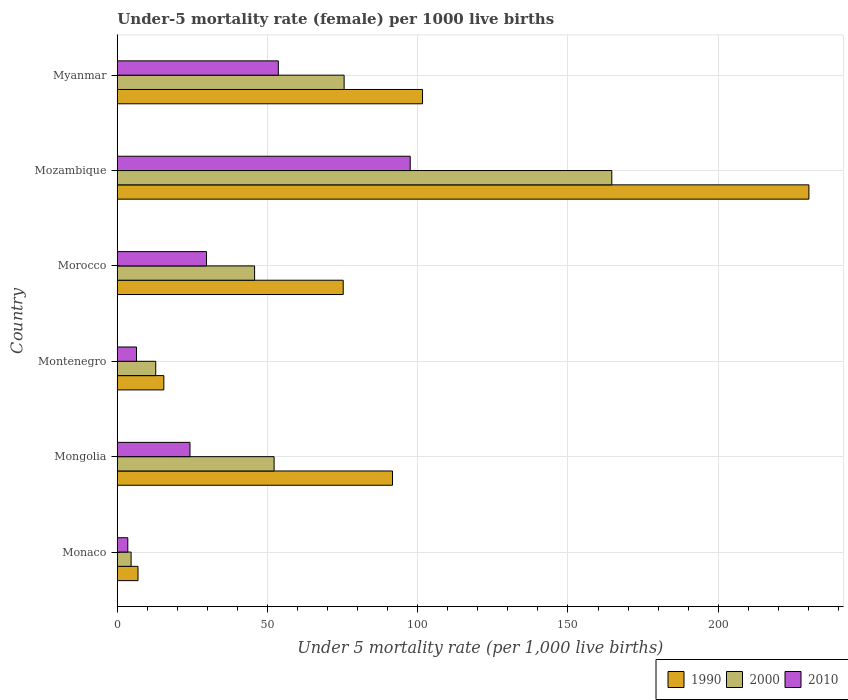How many different coloured bars are there?
Ensure brevity in your answer.  3. Are the number of bars per tick equal to the number of legend labels?
Your answer should be very brief. Yes. Are the number of bars on each tick of the Y-axis equal?
Provide a succinct answer. Yes. How many bars are there on the 4th tick from the top?
Provide a succinct answer. 3. What is the label of the 4th group of bars from the top?
Your answer should be compact. Montenegro. In how many cases, is the number of bars for a given country not equal to the number of legend labels?
Ensure brevity in your answer.  0. What is the under-five mortality rate in 2000 in Myanmar?
Offer a terse response. 75.5. Across all countries, what is the maximum under-five mortality rate in 1990?
Your response must be concise. 230.2. Across all countries, what is the minimum under-five mortality rate in 2000?
Provide a short and direct response. 4.6. In which country was the under-five mortality rate in 1990 maximum?
Your answer should be compact. Mozambique. In which country was the under-five mortality rate in 1990 minimum?
Keep it short and to the point. Monaco. What is the total under-five mortality rate in 2010 in the graph?
Your answer should be very brief. 214.9. What is the difference between the under-five mortality rate in 2000 in Mongolia and that in Mozambique?
Give a very brief answer. -112.4. What is the difference between the under-five mortality rate in 1990 in Myanmar and the under-five mortality rate in 2010 in Montenegro?
Make the answer very short. 95.2. What is the average under-five mortality rate in 2010 per country?
Offer a very short reply. 35.82. What is the difference between the under-five mortality rate in 2010 and under-five mortality rate in 1990 in Morocco?
Provide a succinct answer. -45.5. In how many countries, is the under-five mortality rate in 1990 greater than 220 ?
Give a very brief answer. 1. What is the ratio of the under-five mortality rate in 2000 in Morocco to that in Mozambique?
Keep it short and to the point. 0.28. What is the difference between the highest and the second highest under-five mortality rate in 2010?
Give a very brief answer. 43.9. What is the difference between the highest and the lowest under-five mortality rate in 2000?
Your answer should be very brief. 160. Is the sum of the under-five mortality rate in 2000 in Monaco and Morocco greater than the maximum under-five mortality rate in 1990 across all countries?
Your response must be concise. No. What does the 1st bar from the bottom in Montenegro represents?
Provide a short and direct response. 1990. Is it the case that in every country, the sum of the under-five mortality rate in 2010 and under-five mortality rate in 1990 is greater than the under-five mortality rate in 2000?
Offer a terse response. Yes. How many countries are there in the graph?
Your answer should be compact. 6. Where does the legend appear in the graph?
Keep it short and to the point. Bottom right. How are the legend labels stacked?
Offer a very short reply. Horizontal. What is the title of the graph?
Ensure brevity in your answer.  Under-5 mortality rate (female) per 1000 live births. What is the label or title of the X-axis?
Provide a short and direct response. Under 5 mortality rate (per 1,0 live births). What is the label or title of the Y-axis?
Ensure brevity in your answer.  Country. What is the Under 5 mortality rate (per 1,000 live births) in 1990 in Monaco?
Ensure brevity in your answer.  6.9. What is the Under 5 mortality rate (per 1,000 live births) in 2000 in Monaco?
Your answer should be compact. 4.6. What is the Under 5 mortality rate (per 1,000 live births) in 2010 in Monaco?
Offer a terse response. 3.5. What is the Under 5 mortality rate (per 1,000 live births) of 1990 in Mongolia?
Provide a succinct answer. 91.6. What is the Under 5 mortality rate (per 1,000 live births) in 2000 in Mongolia?
Provide a succinct answer. 52.2. What is the Under 5 mortality rate (per 1,000 live births) of 2010 in Mongolia?
Make the answer very short. 24.2. What is the Under 5 mortality rate (per 1,000 live births) of 1990 in Montenegro?
Provide a succinct answer. 15.5. What is the Under 5 mortality rate (per 1,000 live births) of 2010 in Montenegro?
Ensure brevity in your answer.  6.4. What is the Under 5 mortality rate (per 1,000 live births) of 1990 in Morocco?
Make the answer very short. 75.2. What is the Under 5 mortality rate (per 1,000 live births) of 2000 in Morocco?
Provide a short and direct response. 45.7. What is the Under 5 mortality rate (per 1,000 live births) of 2010 in Morocco?
Provide a succinct answer. 29.7. What is the Under 5 mortality rate (per 1,000 live births) in 1990 in Mozambique?
Offer a very short reply. 230.2. What is the Under 5 mortality rate (per 1,000 live births) in 2000 in Mozambique?
Keep it short and to the point. 164.6. What is the Under 5 mortality rate (per 1,000 live births) in 2010 in Mozambique?
Keep it short and to the point. 97.5. What is the Under 5 mortality rate (per 1,000 live births) in 1990 in Myanmar?
Your answer should be compact. 101.6. What is the Under 5 mortality rate (per 1,000 live births) in 2000 in Myanmar?
Keep it short and to the point. 75.5. What is the Under 5 mortality rate (per 1,000 live births) in 2010 in Myanmar?
Provide a succinct answer. 53.6. Across all countries, what is the maximum Under 5 mortality rate (per 1,000 live births) in 1990?
Keep it short and to the point. 230.2. Across all countries, what is the maximum Under 5 mortality rate (per 1,000 live births) of 2000?
Ensure brevity in your answer.  164.6. Across all countries, what is the maximum Under 5 mortality rate (per 1,000 live births) of 2010?
Ensure brevity in your answer.  97.5. Across all countries, what is the minimum Under 5 mortality rate (per 1,000 live births) in 2010?
Your response must be concise. 3.5. What is the total Under 5 mortality rate (per 1,000 live births) in 1990 in the graph?
Provide a short and direct response. 521. What is the total Under 5 mortality rate (per 1,000 live births) in 2000 in the graph?
Keep it short and to the point. 355.4. What is the total Under 5 mortality rate (per 1,000 live births) in 2010 in the graph?
Your response must be concise. 214.9. What is the difference between the Under 5 mortality rate (per 1,000 live births) of 1990 in Monaco and that in Mongolia?
Keep it short and to the point. -84.7. What is the difference between the Under 5 mortality rate (per 1,000 live births) in 2000 in Monaco and that in Mongolia?
Provide a succinct answer. -47.6. What is the difference between the Under 5 mortality rate (per 1,000 live births) of 2010 in Monaco and that in Mongolia?
Offer a terse response. -20.7. What is the difference between the Under 5 mortality rate (per 1,000 live births) in 1990 in Monaco and that in Montenegro?
Offer a terse response. -8.6. What is the difference between the Under 5 mortality rate (per 1,000 live births) in 2010 in Monaco and that in Montenegro?
Your answer should be compact. -2.9. What is the difference between the Under 5 mortality rate (per 1,000 live births) of 1990 in Monaco and that in Morocco?
Provide a succinct answer. -68.3. What is the difference between the Under 5 mortality rate (per 1,000 live births) of 2000 in Monaco and that in Morocco?
Provide a short and direct response. -41.1. What is the difference between the Under 5 mortality rate (per 1,000 live births) in 2010 in Monaco and that in Morocco?
Provide a short and direct response. -26.2. What is the difference between the Under 5 mortality rate (per 1,000 live births) in 1990 in Monaco and that in Mozambique?
Ensure brevity in your answer.  -223.3. What is the difference between the Under 5 mortality rate (per 1,000 live births) in 2000 in Monaco and that in Mozambique?
Your answer should be very brief. -160. What is the difference between the Under 5 mortality rate (per 1,000 live births) in 2010 in Monaco and that in Mozambique?
Your answer should be very brief. -94. What is the difference between the Under 5 mortality rate (per 1,000 live births) in 1990 in Monaco and that in Myanmar?
Provide a succinct answer. -94.7. What is the difference between the Under 5 mortality rate (per 1,000 live births) in 2000 in Monaco and that in Myanmar?
Make the answer very short. -70.9. What is the difference between the Under 5 mortality rate (per 1,000 live births) in 2010 in Monaco and that in Myanmar?
Your response must be concise. -50.1. What is the difference between the Under 5 mortality rate (per 1,000 live births) in 1990 in Mongolia and that in Montenegro?
Your answer should be very brief. 76.1. What is the difference between the Under 5 mortality rate (per 1,000 live births) of 2000 in Mongolia and that in Montenegro?
Your answer should be compact. 39.4. What is the difference between the Under 5 mortality rate (per 1,000 live births) of 1990 in Mongolia and that in Morocco?
Your answer should be compact. 16.4. What is the difference between the Under 5 mortality rate (per 1,000 live births) in 1990 in Mongolia and that in Mozambique?
Give a very brief answer. -138.6. What is the difference between the Under 5 mortality rate (per 1,000 live births) of 2000 in Mongolia and that in Mozambique?
Ensure brevity in your answer.  -112.4. What is the difference between the Under 5 mortality rate (per 1,000 live births) in 2010 in Mongolia and that in Mozambique?
Make the answer very short. -73.3. What is the difference between the Under 5 mortality rate (per 1,000 live births) of 1990 in Mongolia and that in Myanmar?
Ensure brevity in your answer.  -10. What is the difference between the Under 5 mortality rate (per 1,000 live births) in 2000 in Mongolia and that in Myanmar?
Give a very brief answer. -23.3. What is the difference between the Under 5 mortality rate (per 1,000 live births) of 2010 in Mongolia and that in Myanmar?
Offer a terse response. -29.4. What is the difference between the Under 5 mortality rate (per 1,000 live births) of 1990 in Montenegro and that in Morocco?
Your response must be concise. -59.7. What is the difference between the Under 5 mortality rate (per 1,000 live births) in 2000 in Montenegro and that in Morocco?
Keep it short and to the point. -32.9. What is the difference between the Under 5 mortality rate (per 1,000 live births) in 2010 in Montenegro and that in Morocco?
Keep it short and to the point. -23.3. What is the difference between the Under 5 mortality rate (per 1,000 live births) of 1990 in Montenegro and that in Mozambique?
Provide a succinct answer. -214.7. What is the difference between the Under 5 mortality rate (per 1,000 live births) in 2000 in Montenegro and that in Mozambique?
Ensure brevity in your answer.  -151.8. What is the difference between the Under 5 mortality rate (per 1,000 live births) of 2010 in Montenegro and that in Mozambique?
Your answer should be compact. -91.1. What is the difference between the Under 5 mortality rate (per 1,000 live births) in 1990 in Montenegro and that in Myanmar?
Give a very brief answer. -86.1. What is the difference between the Under 5 mortality rate (per 1,000 live births) of 2000 in Montenegro and that in Myanmar?
Your response must be concise. -62.7. What is the difference between the Under 5 mortality rate (per 1,000 live births) in 2010 in Montenegro and that in Myanmar?
Provide a succinct answer. -47.2. What is the difference between the Under 5 mortality rate (per 1,000 live births) in 1990 in Morocco and that in Mozambique?
Your answer should be very brief. -155. What is the difference between the Under 5 mortality rate (per 1,000 live births) in 2000 in Morocco and that in Mozambique?
Offer a terse response. -118.9. What is the difference between the Under 5 mortality rate (per 1,000 live births) of 2010 in Morocco and that in Mozambique?
Provide a succinct answer. -67.8. What is the difference between the Under 5 mortality rate (per 1,000 live births) in 1990 in Morocco and that in Myanmar?
Offer a very short reply. -26.4. What is the difference between the Under 5 mortality rate (per 1,000 live births) of 2000 in Morocco and that in Myanmar?
Give a very brief answer. -29.8. What is the difference between the Under 5 mortality rate (per 1,000 live births) of 2010 in Morocco and that in Myanmar?
Your answer should be compact. -23.9. What is the difference between the Under 5 mortality rate (per 1,000 live births) in 1990 in Mozambique and that in Myanmar?
Offer a terse response. 128.6. What is the difference between the Under 5 mortality rate (per 1,000 live births) of 2000 in Mozambique and that in Myanmar?
Provide a succinct answer. 89.1. What is the difference between the Under 5 mortality rate (per 1,000 live births) in 2010 in Mozambique and that in Myanmar?
Your answer should be very brief. 43.9. What is the difference between the Under 5 mortality rate (per 1,000 live births) of 1990 in Monaco and the Under 5 mortality rate (per 1,000 live births) of 2000 in Mongolia?
Your answer should be very brief. -45.3. What is the difference between the Under 5 mortality rate (per 1,000 live births) in 1990 in Monaco and the Under 5 mortality rate (per 1,000 live births) in 2010 in Mongolia?
Your answer should be very brief. -17.3. What is the difference between the Under 5 mortality rate (per 1,000 live births) of 2000 in Monaco and the Under 5 mortality rate (per 1,000 live births) of 2010 in Mongolia?
Your answer should be compact. -19.6. What is the difference between the Under 5 mortality rate (per 1,000 live births) in 1990 in Monaco and the Under 5 mortality rate (per 1,000 live births) in 2000 in Morocco?
Your answer should be very brief. -38.8. What is the difference between the Under 5 mortality rate (per 1,000 live births) of 1990 in Monaco and the Under 5 mortality rate (per 1,000 live births) of 2010 in Morocco?
Offer a very short reply. -22.8. What is the difference between the Under 5 mortality rate (per 1,000 live births) in 2000 in Monaco and the Under 5 mortality rate (per 1,000 live births) in 2010 in Morocco?
Your answer should be compact. -25.1. What is the difference between the Under 5 mortality rate (per 1,000 live births) of 1990 in Monaco and the Under 5 mortality rate (per 1,000 live births) of 2000 in Mozambique?
Provide a short and direct response. -157.7. What is the difference between the Under 5 mortality rate (per 1,000 live births) in 1990 in Monaco and the Under 5 mortality rate (per 1,000 live births) in 2010 in Mozambique?
Your answer should be very brief. -90.6. What is the difference between the Under 5 mortality rate (per 1,000 live births) of 2000 in Monaco and the Under 5 mortality rate (per 1,000 live births) of 2010 in Mozambique?
Your answer should be very brief. -92.9. What is the difference between the Under 5 mortality rate (per 1,000 live births) in 1990 in Monaco and the Under 5 mortality rate (per 1,000 live births) in 2000 in Myanmar?
Your response must be concise. -68.6. What is the difference between the Under 5 mortality rate (per 1,000 live births) in 1990 in Monaco and the Under 5 mortality rate (per 1,000 live births) in 2010 in Myanmar?
Provide a short and direct response. -46.7. What is the difference between the Under 5 mortality rate (per 1,000 live births) of 2000 in Monaco and the Under 5 mortality rate (per 1,000 live births) of 2010 in Myanmar?
Your answer should be very brief. -49. What is the difference between the Under 5 mortality rate (per 1,000 live births) in 1990 in Mongolia and the Under 5 mortality rate (per 1,000 live births) in 2000 in Montenegro?
Offer a very short reply. 78.8. What is the difference between the Under 5 mortality rate (per 1,000 live births) of 1990 in Mongolia and the Under 5 mortality rate (per 1,000 live births) of 2010 in Montenegro?
Your answer should be very brief. 85.2. What is the difference between the Under 5 mortality rate (per 1,000 live births) in 2000 in Mongolia and the Under 5 mortality rate (per 1,000 live births) in 2010 in Montenegro?
Your answer should be very brief. 45.8. What is the difference between the Under 5 mortality rate (per 1,000 live births) in 1990 in Mongolia and the Under 5 mortality rate (per 1,000 live births) in 2000 in Morocco?
Make the answer very short. 45.9. What is the difference between the Under 5 mortality rate (per 1,000 live births) of 1990 in Mongolia and the Under 5 mortality rate (per 1,000 live births) of 2010 in Morocco?
Provide a succinct answer. 61.9. What is the difference between the Under 5 mortality rate (per 1,000 live births) in 1990 in Mongolia and the Under 5 mortality rate (per 1,000 live births) in 2000 in Mozambique?
Keep it short and to the point. -73. What is the difference between the Under 5 mortality rate (per 1,000 live births) of 1990 in Mongolia and the Under 5 mortality rate (per 1,000 live births) of 2010 in Mozambique?
Provide a succinct answer. -5.9. What is the difference between the Under 5 mortality rate (per 1,000 live births) of 2000 in Mongolia and the Under 5 mortality rate (per 1,000 live births) of 2010 in Mozambique?
Make the answer very short. -45.3. What is the difference between the Under 5 mortality rate (per 1,000 live births) in 1990 in Mongolia and the Under 5 mortality rate (per 1,000 live births) in 2000 in Myanmar?
Provide a short and direct response. 16.1. What is the difference between the Under 5 mortality rate (per 1,000 live births) in 1990 in Mongolia and the Under 5 mortality rate (per 1,000 live births) in 2010 in Myanmar?
Provide a succinct answer. 38. What is the difference between the Under 5 mortality rate (per 1,000 live births) of 2000 in Mongolia and the Under 5 mortality rate (per 1,000 live births) of 2010 in Myanmar?
Make the answer very short. -1.4. What is the difference between the Under 5 mortality rate (per 1,000 live births) of 1990 in Montenegro and the Under 5 mortality rate (per 1,000 live births) of 2000 in Morocco?
Ensure brevity in your answer.  -30.2. What is the difference between the Under 5 mortality rate (per 1,000 live births) in 2000 in Montenegro and the Under 5 mortality rate (per 1,000 live births) in 2010 in Morocco?
Provide a short and direct response. -16.9. What is the difference between the Under 5 mortality rate (per 1,000 live births) of 1990 in Montenegro and the Under 5 mortality rate (per 1,000 live births) of 2000 in Mozambique?
Ensure brevity in your answer.  -149.1. What is the difference between the Under 5 mortality rate (per 1,000 live births) in 1990 in Montenegro and the Under 5 mortality rate (per 1,000 live births) in 2010 in Mozambique?
Offer a terse response. -82. What is the difference between the Under 5 mortality rate (per 1,000 live births) in 2000 in Montenegro and the Under 5 mortality rate (per 1,000 live births) in 2010 in Mozambique?
Your answer should be compact. -84.7. What is the difference between the Under 5 mortality rate (per 1,000 live births) in 1990 in Montenegro and the Under 5 mortality rate (per 1,000 live births) in 2000 in Myanmar?
Ensure brevity in your answer.  -60. What is the difference between the Under 5 mortality rate (per 1,000 live births) of 1990 in Montenegro and the Under 5 mortality rate (per 1,000 live births) of 2010 in Myanmar?
Give a very brief answer. -38.1. What is the difference between the Under 5 mortality rate (per 1,000 live births) in 2000 in Montenegro and the Under 5 mortality rate (per 1,000 live births) in 2010 in Myanmar?
Offer a very short reply. -40.8. What is the difference between the Under 5 mortality rate (per 1,000 live births) of 1990 in Morocco and the Under 5 mortality rate (per 1,000 live births) of 2000 in Mozambique?
Your response must be concise. -89.4. What is the difference between the Under 5 mortality rate (per 1,000 live births) of 1990 in Morocco and the Under 5 mortality rate (per 1,000 live births) of 2010 in Mozambique?
Provide a succinct answer. -22.3. What is the difference between the Under 5 mortality rate (per 1,000 live births) of 2000 in Morocco and the Under 5 mortality rate (per 1,000 live births) of 2010 in Mozambique?
Offer a very short reply. -51.8. What is the difference between the Under 5 mortality rate (per 1,000 live births) of 1990 in Morocco and the Under 5 mortality rate (per 1,000 live births) of 2010 in Myanmar?
Provide a succinct answer. 21.6. What is the difference between the Under 5 mortality rate (per 1,000 live births) in 1990 in Mozambique and the Under 5 mortality rate (per 1,000 live births) in 2000 in Myanmar?
Offer a terse response. 154.7. What is the difference between the Under 5 mortality rate (per 1,000 live births) of 1990 in Mozambique and the Under 5 mortality rate (per 1,000 live births) of 2010 in Myanmar?
Give a very brief answer. 176.6. What is the difference between the Under 5 mortality rate (per 1,000 live births) in 2000 in Mozambique and the Under 5 mortality rate (per 1,000 live births) in 2010 in Myanmar?
Keep it short and to the point. 111. What is the average Under 5 mortality rate (per 1,000 live births) in 1990 per country?
Provide a short and direct response. 86.83. What is the average Under 5 mortality rate (per 1,000 live births) in 2000 per country?
Provide a short and direct response. 59.23. What is the average Under 5 mortality rate (per 1,000 live births) of 2010 per country?
Provide a succinct answer. 35.82. What is the difference between the Under 5 mortality rate (per 1,000 live births) of 1990 and Under 5 mortality rate (per 1,000 live births) of 2000 in Monaco?
Keep it short and to the point. 2.3. What is the difference between the Under 5 mortality rate (per 1,000 live births) of 2000 and Under 5 mortality rate (per 1,000 live births) of 2010 in Monaco?
Offer a very short reply. 1.1. What is the difference between the Under 5 mortality rate (per 1,000 live births) of 1990 and Under 5 mortality rate (per 1,000 live births) of 2000 in Mongolia?
Your response must be concise. 39.4. What is the difference between the Under 5 mortality rate (per 1,000 live births) in 1990 and Under 5 mortality rate (per 1,000 live births) in 2010 in Mongolia?
Give a very brief answer. 67.4. What is the difference between the Under 5 mortality rate (per 1,000 live births) in 1990 and Under 5 mortality rate (per 1,000 live births) in 2010 in Montenegro?
Offer a very short reply. 9.1. What is the difference between the Under 5 mortality rate (per 1,000 live births) of 2000 and Under 5 mortality rate (per 1,000 live births) of 2010 in Montenegro?
Your answer should be very brief. 6.4. What is the difference between the Under 5 mortality rate (per 1,000 live births) in 1990 and Under 5 mortality rate (per 1,000 live births) in 2000 in Morocco?
Make the answer very short. 29.5. What is the difference between the Under 5 mortality rate (per 1,000 live births) in 1990 and Under 5 mortality rate (per 1,000 live births) in 2010 in Morocco?
Provide a succinct answer. 45.5. What is the difference between the Under 5 mortality rate (per 1,000 live births) of 1990 and Under 5 mortality rate (per 1,000 live births) of 2000 in Mozambique?
Offer a terse response. 65.6. What is the difference between the Under 5 mortality rate (per 1,000 live births) in 1990 and Under 5 mortality rate (per 1,000 live births) in 2010 in Mozambique?
Provide a succinct answer. 132.7. What is the difference between the Under 5 mortality rate (per 1,000 live births) of 2000 and Under 5 mortality rate (per 1,000 live births) of 2010 in Mozambique?
Offer a terse response. 67.1. What is the difference between the Under 5 mortality rate (per 1,000 live births) in 1990 and Under 5 mortality rate (per 1,000 live births) in 2000 in Myanmar?
Make the answer very short. 26.1. What is the difference between the Under 5 mortality rate (per 1,000 live births) of 2000 and Under 5 mortality rate (per 1,000 live births) of 2010 in Myanmar?
Offer a very short reply. 21.9. What is the ratio of the Under 5 mortality rate (per 1,000 live births) of 1990 in Monaco to that in Mongolia?
Offer a terse response. 0.08. What is the ratio of the Under 5 mortality rate (per 1,000 live births) in 2000 in Monaco to that in Mongolia?
Provide a short and direct response. 0.09. What is the ratio of the Under 5 mortality rate (per 1,000 live births) in 2010 in Monaco to that in Mongolia?
Offer a terse response. 0.14. What is the ratio of the Under 5 mortality rate (per 1,000 live births) of 1990 in Monaco to that in Montenegro?
Offer a terse response. 0.45. What is the ratio of the Under 5 mortality rate (per 1,000 live births) in 2000 in Monaco to that in Montenegro?
Offer a very short reply. 0.36. What is the ratio of the Under 5 mortality rate (per 1,000 live births) in 2010 in Monaco to that in Montenegro?
Offer a very short reply. 0.55. What is the ratio of the Under 5 mortality rate (per 1,000 live births) in 1990 in Monaco to that in Morocco?
Offer a terse response. 0.09. What is the ratio of the Under 5 mortality rate (per 1,000 live births) in 2000 in Monaco to that in Morocco?
Make the answer very short. 0.1. What is the ratio of the Under 5 mortality rate (per 1,000 live births) in 2010 in Monaco to that in Morocco?
Ensure brevity in your answer.  0.12. What is the ratio of the Under 5 mortality rate (per 1,000 live births) of 1990 in Monaco to that in Mozambique?
Make the answer very short. 0.03. What is the ratio of the Under 5 mortality rate (per 1,000 live births) of 2000 in Monaco to that in Mozambique?
Your answer should be very brief. 0.03. What is the ratio of the Under 5 mortality rate (per 1,000 live births) of 2010 in Monaco to that in Mozambique?
Provide a short and direct response. 0.04. What is the ratio of the Under 5 mortality rate (per 1,000 live births) in 1990 in Monaco to that in Myanmar?
Your answer should be compact. 0.07. What is the ratio of the Under 5 mortality rate (per 1,000 live births) of 2000 in Monaco to that in Myanmar?
Provide a succinct answer. 0.06. What is the ratio of the Under 5 mortality rate (per 1,000 live births) of 2010 in Monaco to that in Myanmar?
Offer a terse response. 0.07. What is the ratio of the Under 5 mortality rate (per 1,000 live births) in 1990 in Mongolia to that in Montenegro?
Offer a very short reply. 5.91. What is the ratio of the Under 5 mortality rate (per 1,000 live births) in 2000 in Mongolia to that in Montenegro?
Your answer should be very brief. 4.08. What is the ratio of the Under 5 mortality rate (per 1,000 live births) in 2010 in Mongolia to that in Montenegro?
Your answer should be very brief. 3.78. What is the ratio of the Under 5 mortality rate (per 1,000 live births) in 1990 in Mongolia to that in Morocco?
Ensure brevity in your answer.  1.22. What is the ratio of the Under 5 mortality rate (per 1,000 live births) in 2000 in Mongolia to that in Morocco?
Ensure brevity in your answer.  1.14. What is the ratio of the Under 5 mortality rate (per 1,000 live births) of 2010 in Mongolia to that in Morocco?
Your response must be concise. 0.81. What is the ratio of the Under 5 mortality rate (per 1,000 live births) in 1990 in Mongolia to that in Mozambique?
Offer a very short reply. 0.4. What is the ratio of the Under 5 mortality rate (per 1,000 live births) of 2000 in Mongolia to that in Mozambique?
Your answer should be compact. 0.32. What is the ratio of the Under 5 mortality rate (per 1,000 live births) in 2010 in Mongolia to that in Mozambique?
Make the answer very short. 0.25. What is the ratio of the Under 5 mortality rate (per 1,000 live births) of 1990 in Mongolia to that in Myanmar?
Make the answer very short. 0.9. What is the ratio of the Under 5 mortality rate (per 1,000 live births) in 2000 in Mongolia to that in Myanmar?
Provide a short and direct response. 0.69. What is the ratio of the Under 5 mortality rate (per 1,000 live births) of 2010 in Mongolia to that in Myanmar?
Your response must be concise. 0.45. What is the ratio of the Under 5 mortality rate (per 1,000 live births) in 1990 in Montenegro to that in Morocco?
Offer a terse response. 0.21. What is the ratio of the Under 5 mortality rate (per 1,000 live births) in 2000 in Montenegro to that in Morocco?
Your answer should be very brief. 0.28. What is the ratio of the Under 5 mortality rate (per 1,000 live births) in 2010 in Montenegro to that in Morocco?
Make the answer very short. 0.22. What is the ratio of the Under 5 mortality rate (per 1,000 live births) in 1990 in Montenegro to that in Mozambique?
Make the answer very short. 0.07. What is the ratio of the Under 5 mortality rate (per 1,000 live births) in 2000 in Montenegro to that in Mozambique?
Your response must be concise. 0.08. What is the ratio of the Under 5 mortality rate (per 1,000 live births) in 2010 in Montenegro to that in Mozambique?
Make the answer very short. 0.07. What is the ratio of the Under 5 mortality rate (per 1,000 live births) of 1990 in Montenegro to that in Myanmar?
Your answer should be very brief. 0.15. What is the ratio of the Under 5 mortality rate (per 1,000 live births) in 2000 in Montenegro to that in Myanmar?
Provide a succinct answer. 0.17. What is the ratio of the Under 5 mortality rate (per 1,000 live births) in 2010 in Montenegro to that in Myanmar?
Keep it short and to the point. 0.12. What is the ratio of the Under 5 mortality rate (per 1,000 live births) in 1990 in Morocco to that in Mozambique?
Your answer should be very brief. 0.33. What is the ratio of the Under 5 mortality rate (per 1,000 live births) of 2000 in Morocco to that in Mozambique?
Make the answer very short. 0.28. What is the ratio of the Under 5 mortality rate (per 1,000 live births) of 2010 in Morocco to that in Mozambique?
Offer a terse response. 0.3. What is the ratio of the Under 5 mortality rate (per 1,000 live births) in 1990 in Morocco to that in Myanmar?
Ensure brevity in your answer.  0.74. What is the ratio of the Under 5 mortality rate (per 1,000 live births) in 2000 in Morocco to that in Myanmar?
Your answer should be very brief. 0.61. What is the ratio of the Under 5 mortality rate (per 1,000 live births) of 2010 in Morocco to that in Myanmar?
Your response must be concise. 0.55. What is the ratio of the Under 5 mortality rate (per 1,000 live births) in 1990 in Mozambique to that in Myanmar?
Keep it short and to the point. 2.27. What is the ratio of the Under 5 mortality rate (per 1,000 live births) in 2000 in Mozambique to that in Myanmar?
Give a very brief answer. 2.18. What is the ratio of the Under 5 mortality rate (per 1,000 live births) of 2010 in Mozambique to that in Myanmar?
Offer a terse response. 1.82. What is the difference between the highest and the second highest Under 5 mortality rate (per 1,000 live births) of 1990?
Offer a terse response. 128.6. What is the difference between the highest and the second highest Under 5 mortality rate (per 1,000 live births) of 2000?
Ensure brevity in your answer.  89.1. What is the difference between the highest and the second highest Under 5 mortality rate (per 1,000 live births) of 2010?
Provide a short and direct response. 43.9. What is the difference between the highest and the lowest Under 5 mortality rate (per 1,000 live births) in 1990?
Offer a very short reply. 223.3. What is the difference between the highest and the lowest Under 5 mortality rate (per 1,000 live births) of 2000?
Give a very brief answer. 160. What is the difference between the highest and the lowest Under 5 mortality rate (per 1,000 live births) of 2010?
Your response must be concise. 94. 